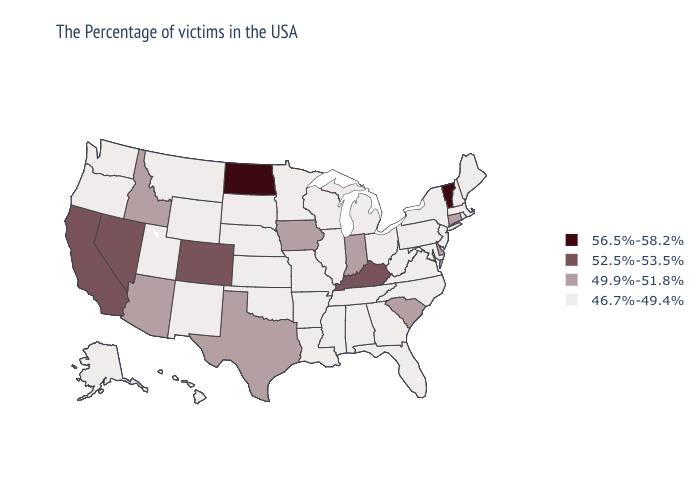Name the states that have a value in the range 56.5%-58.2%?
Be succinct. Vermont, North Dakota. Does the first symbol in the legend represent the smallest category?
Be succinct. No. Name the states that have a value in the range 56.5%-58.2%?
Answer briefly. Vermont, North Dakota. What is the value of Rhode Island?
Quick response, please. 46.7%-49.4%. Among the states that border Arizona , does Colorado have the highest value?
Concise answer only. Yes. Name the states that have a value in the range 49.9%-51.8%?
Keep it brief. Connecticut, Delaware, South Carolina, Indiana, Iowa, Texas, Arizona, Idaho. Does Kentucky have a lower value than North Dakota?
Give a very brief answer. Yes. Does Massachusetts have a lower value than Iowa?
Give a very brief answer. Yes. Name the states that have a value in the range 49.9%-51.8%?
Short answer required. Connecticut, Delaware, South Carolina, Indiana, Iowa, Texas, Arizona, Idaho. Name the states that have a value in the range 56.5%-58.2%?
Concise answer only. Vermont, North Dakota. What is the lowest value in the USA?
Concise answer only. 46.7%-49.4%. Does Nebraska have the highest value in the MidWest?
Write a very short answer. No. Does Arizona have the lowest value in the USA?
Give a very brief answer. No. Is the legend a continuous bar?
Write a very short answer. No. Name the states that have a value in the range 52.5%-53.5%?
Give a very brief answer. Kentucky, Colorado, Nevada, California. 